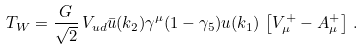<formula> <loc_0><loc_0><loc_500><loc_500>T _ { W } = \frac { G } { \sqrt { 2 } } \, V _ { u d } \bar { u } ( k _ { 2 } ) \gamma ^ { \mu } ( 1 - \gamma _ { 5 } ) u ( k _ { 1 } ) \, \left [ V _ { \mu } ^ { + } - A _ { \mu } ^ { + } \right ] \, .</formula> 